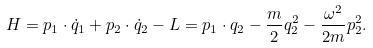Convert formula to latex. <formula><loc_0><loc_0><loc_500><loc_500>H = p _ { 1 } \cdot \dot { q } _ { 1 } + p _ { 2 } \cdot \dot { q } _ { 2 } - L = p _ { 1 } \cdot q _ { 2 } - \frac { m } { 2 } q _ { 2 } ^ { 2 } - \frac { \omega ^ { 2 } } { 2 m } p _ { 2 } ^ { 2 } .</formula> 